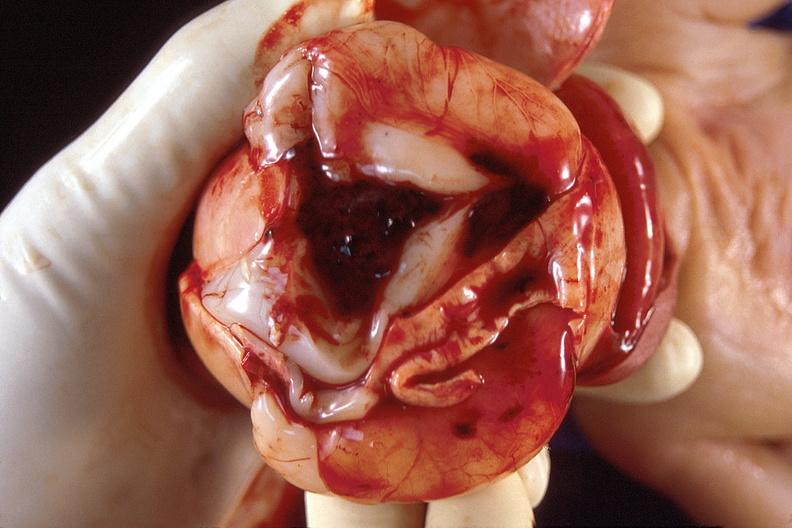does this image show brain, intraventricular hemorrhage?
Answer the question using a single word or phrase. Yes 